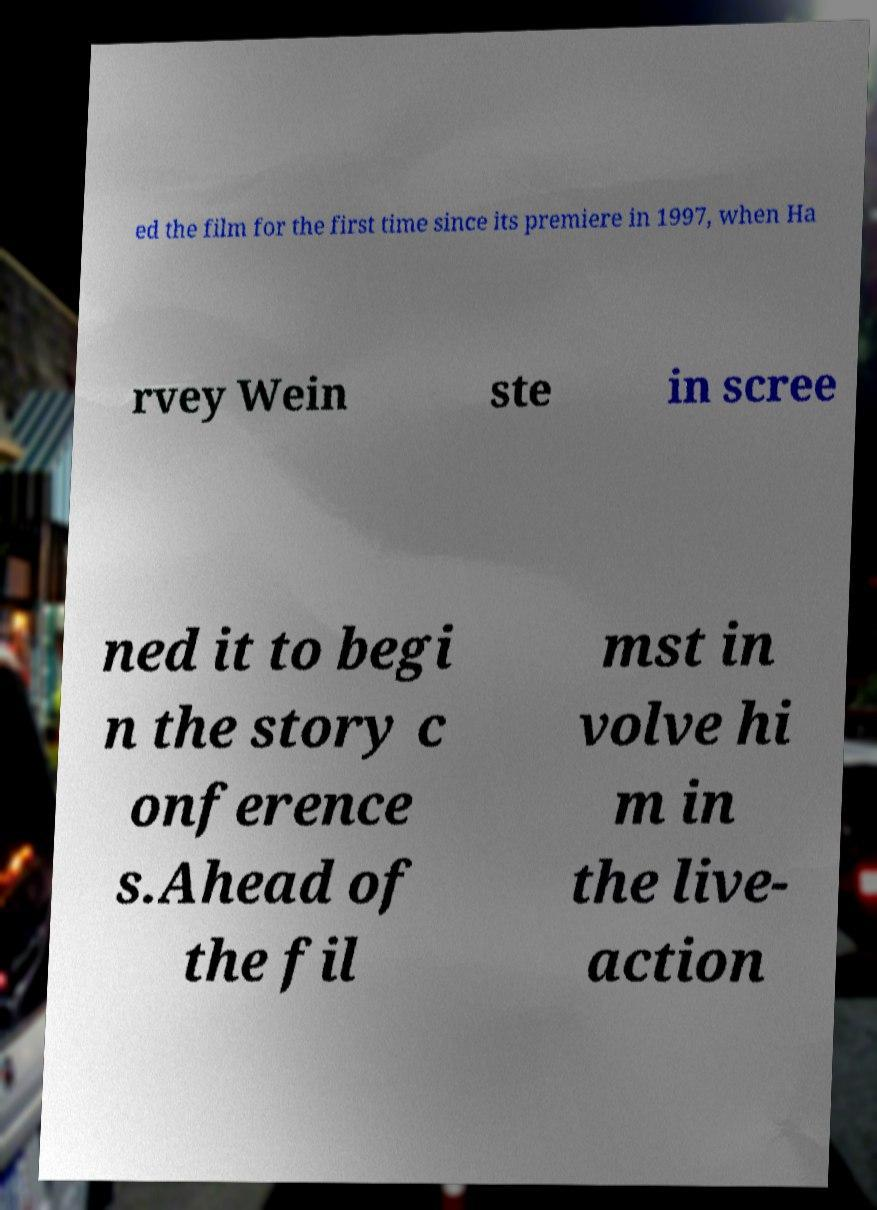Can you read and provide the text displayed in the image?This photo seems to have some interesting text. Can you extract and type it out for me? ed the film for the first time since its premiere in 1997, when Ha rvey Wein ste in scree ned it to begi n the story c onference s.Ahead of the fil mst in volve hi m in the live- action 